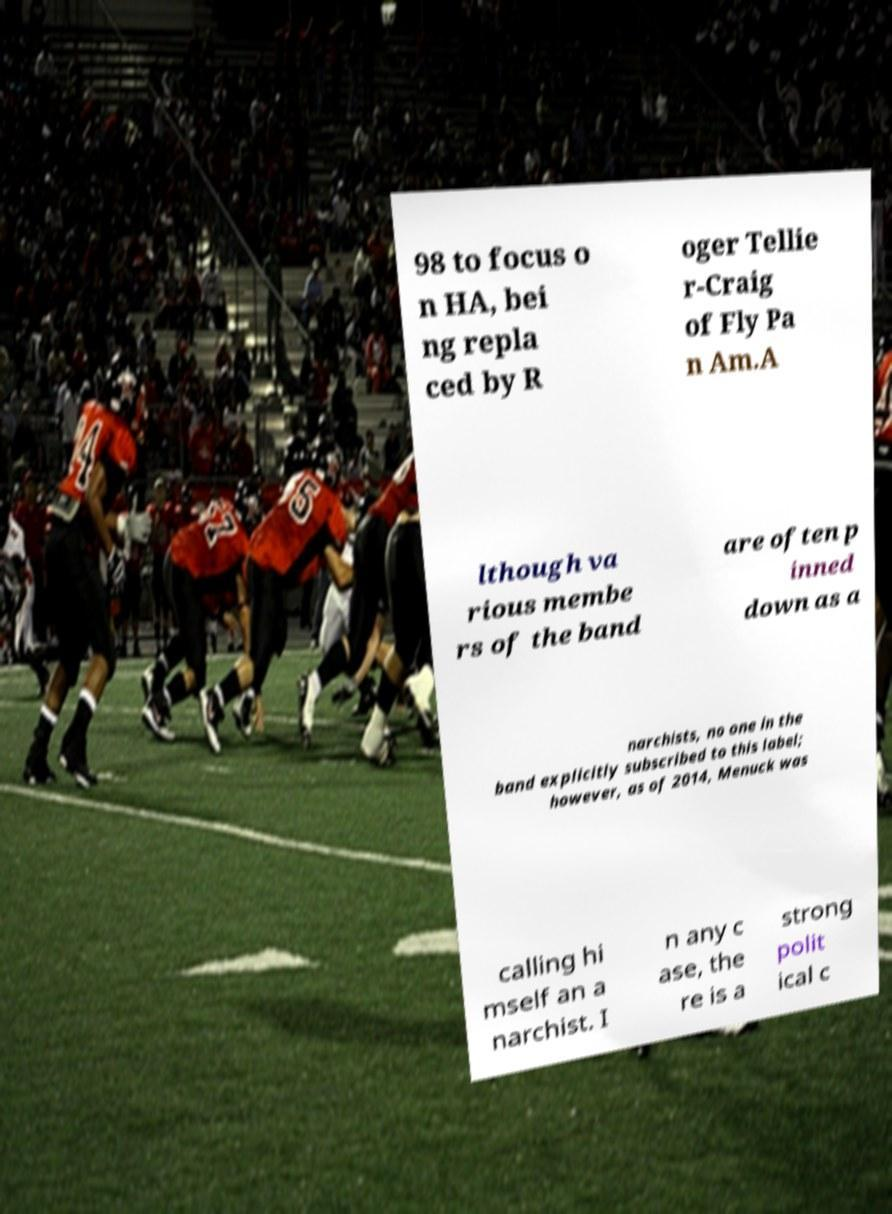For documentation purposes, I need the text within this image transcribed. Could you provide that? 98 to focus o n HA, bei ng repla ced by R oger Tellie r-Craig of Fly Pa n Am.A lthough va rious membe rs of the band are often p inned down as a narchists, no one in the band explicitly subscribed to this label; however, as of 2014, Menuck was calling hi mself an a narchist. I n any c ase, the re is a strong polit ical c 